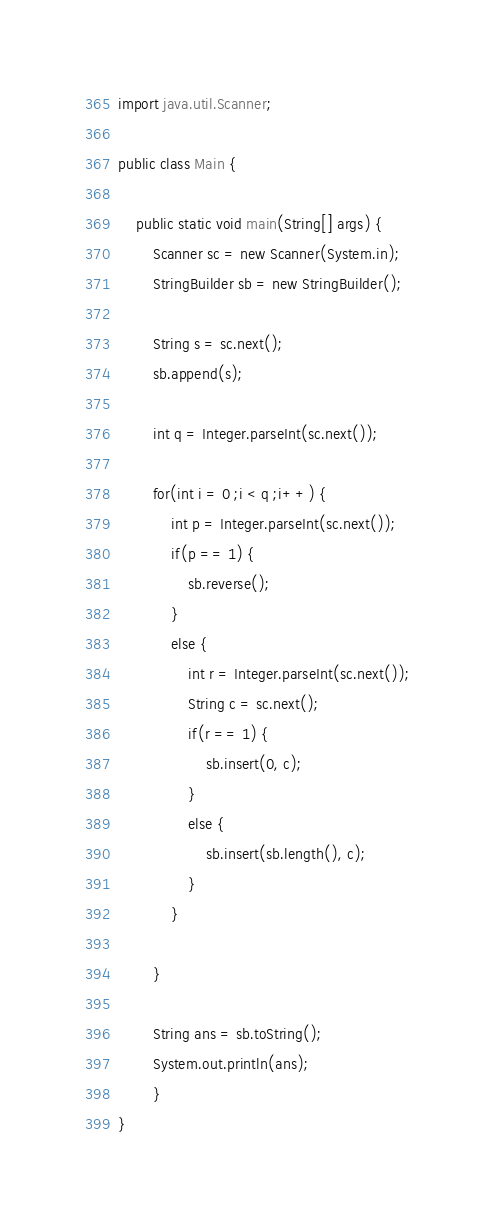Convert code to text. <code><loc_0><loc_0><loc_500><loc_500><_Java_>
import java.util.Scanner;

public class Main {

	public static void main(String[] args) {
		Scanner sc = new Scanner(System.in);
		StringBuilder sb = new StringBuilder();
		
		String s = sc.next();
		sb.append(s);
		
		int q = Integer.parseInt(sc.next());
		
		for(int i = 0 ;i < q ;i++) {
			int p = Integer.parseInt(sc.next());
			if(p == 1) {
				sb.reverse();				
			}
			else {
				int r = Integer.parseInt(sc.next());
				String c = sc.next();
				if(r == 1) {
					sb.insert(0, c);
				}
				else {
					sb.insert(sb.length(), c);
				}
			}
			
		}
		
		String ans = sb.toString();
		System.out.println(ans);
		}
}
</code> 